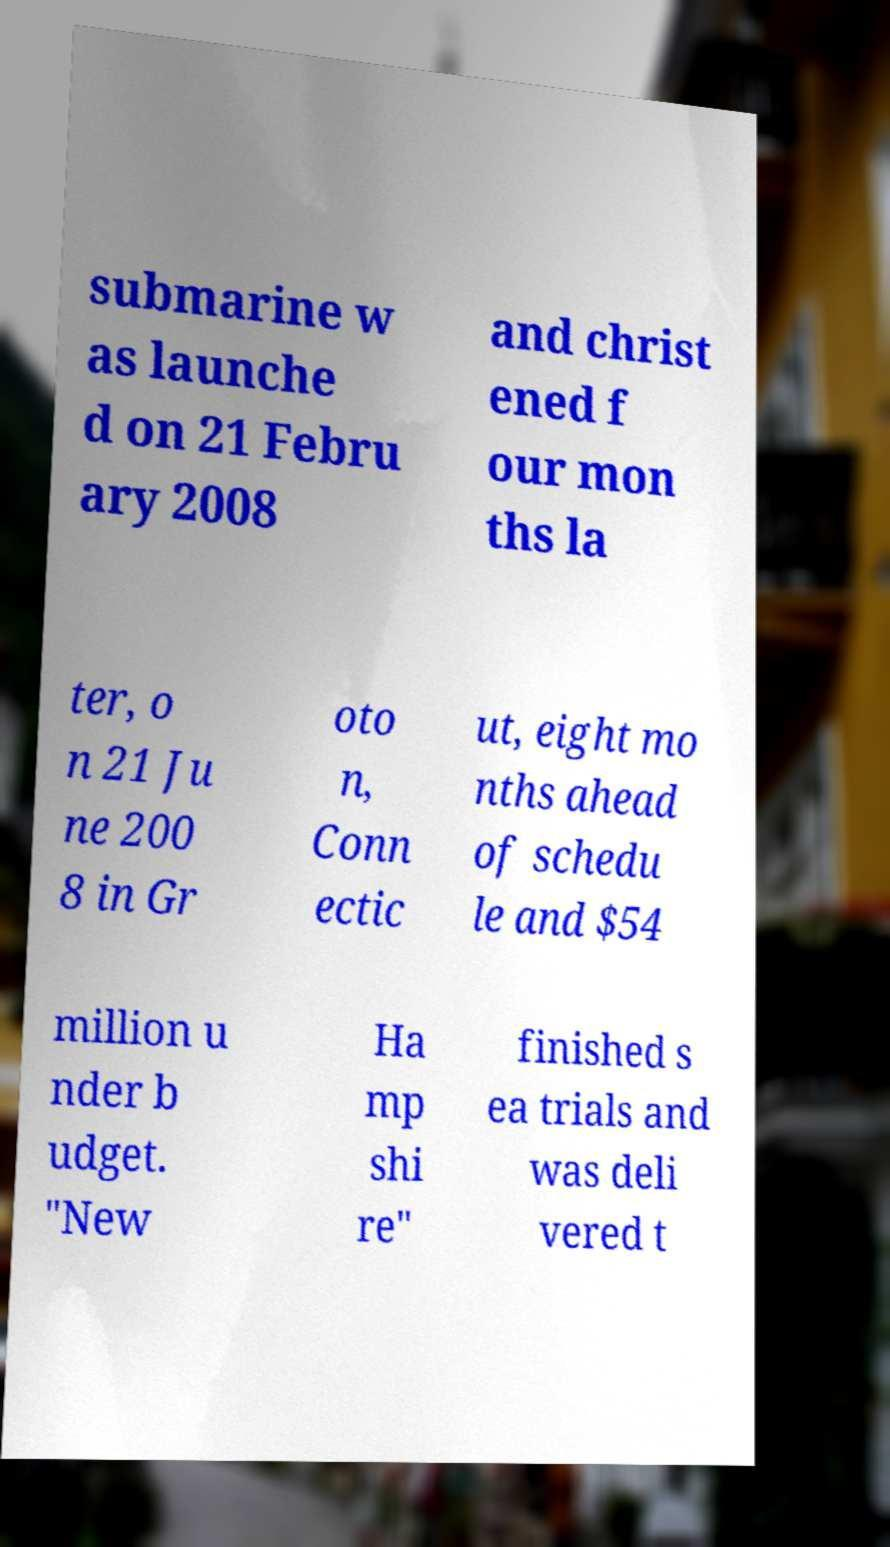Could you extract and type out the text from this image? submarine w as launche d on 21 Febru ary 2008 and christ ened f our mon ths la ter, o n 21 Ju ne 200 8 in Gr oto n, Conn ectic ut, eight mo nths ahead of schedu le and $54 million u nder b udget. "New Ha mp shi re" finished s ea trials and was deli vered t 